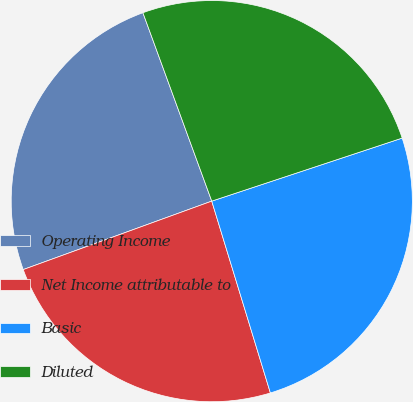<chart> <loc_0><loc_0><loc_500><loc_500><pie_chart><fcel>Operating Income<fcel>Net Income attributable to<fcel>Basic<fcel>Diluted<nl><fcel>24.97%<fcel>24.18%<fcel>25.37%<fcel>25.49%<nl></chart> 